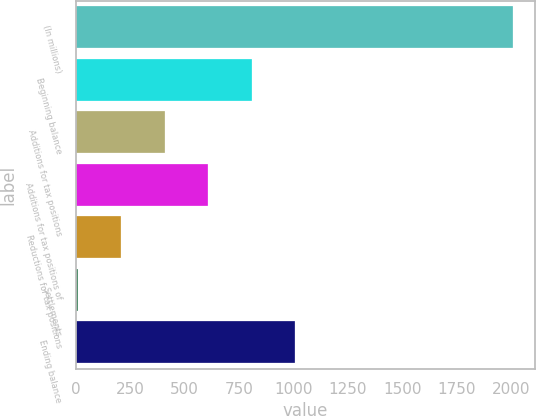Convert chart. <chart><loc_0><loc_0><loc_500><loc_500><bar_chart><fcel>(In millions)<fcel>Beginning balance<fcel>Additions for tax positions<fcel>Additions for tax positions of<fcel>Reductions for tax positions<fcel>Settlements<fcel>Ending balance<nl><fcel>2009<fcel>807.8<fcel>407.4<fcel>607.6<fcel>207.2<fcel>7<fcel>1008<nl></chart> 